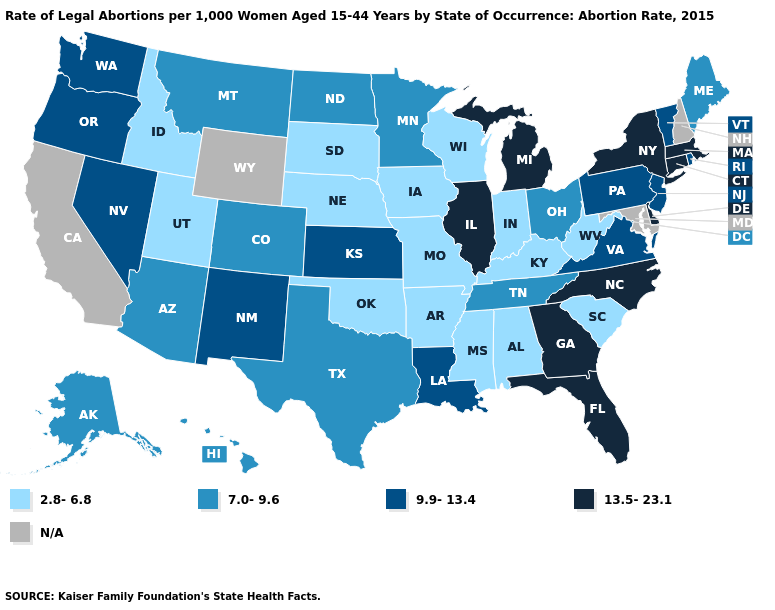Which states hav the highest value in the MidWest?
Write a very short answer. Illinois, Michigan. Which states have the lowest value in the Northeast?
Quick response, please. Maine. What is the lowest value in states that border New Mexico?
Concise answer only. 2.8-6.8. What is the highest value in the West ?
Write a very short answer. 9.9-13.4. Name the states that have a value in the range 7.0-9.6?
Short answer required. Alaska, Arizona, Colorado, Hawaii, Maine, Minnesota, Montana, North Dakota, Ohio, Tennessee, Texas. Among the states that border New Mexico , which have the highest value?
Write a very short answer. Arizona, Colorado, Texas. Which states hav the highest value in the West?
Short answer required. Nevada, New Mexico, Oregon, Washington. What is the value of Arkansas?
Answer briefly. 2.8-6.8. Is the legend a continuous bar?
Be succinct. No. Does Iowa have the lowest value in the USA?
Write a very short answer. Yes. Name the states that have a value in the range 7.0-9.6?
Short answer required. Alaska, Arizona, Colorado, Hawaii, Maine, Minnesota, Montana, North Dakota, Ohio, Tennessee, Texas. Does New Mexico have the highest value in the USA?
Keep it brief. No. Does Florida have the highest value in the USA?
Write a very short answer. Yes. Among the states that border Iowa , does Minnesota have the lowest value?
Be succinct. No. Does the map have missing data?
Be succinct. Yes. 